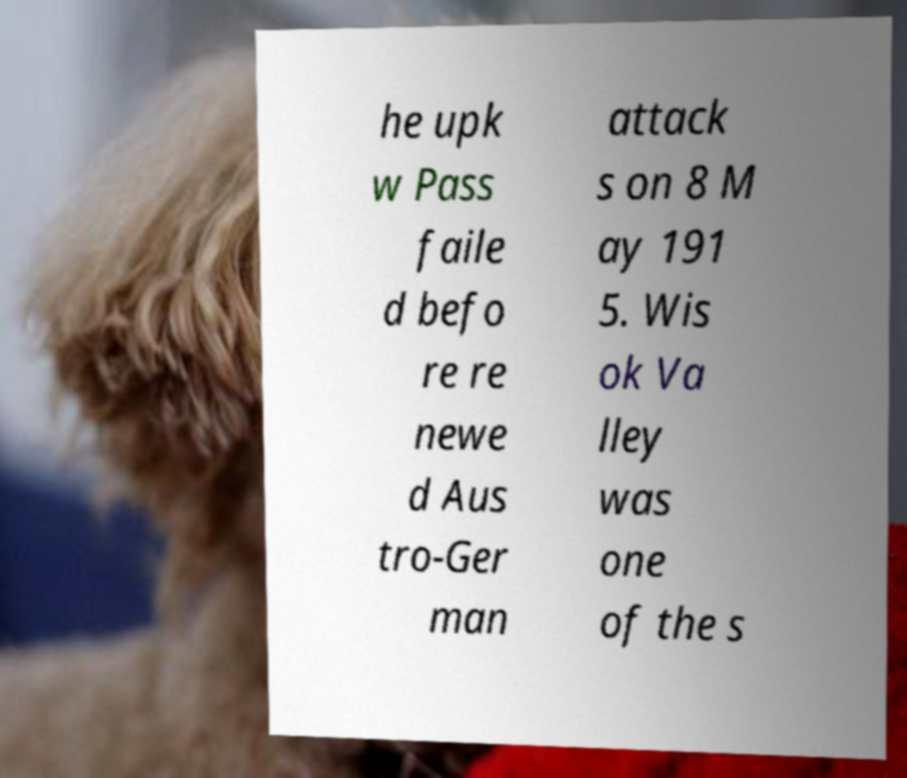What messages or text are displayed in this image? I need them in a readable, typed format. he upk w Pass faile d befo re re newe d Aus tro-Ger man attack s on 8 M ay 191 5. Wis ok Va lley was one of the s 